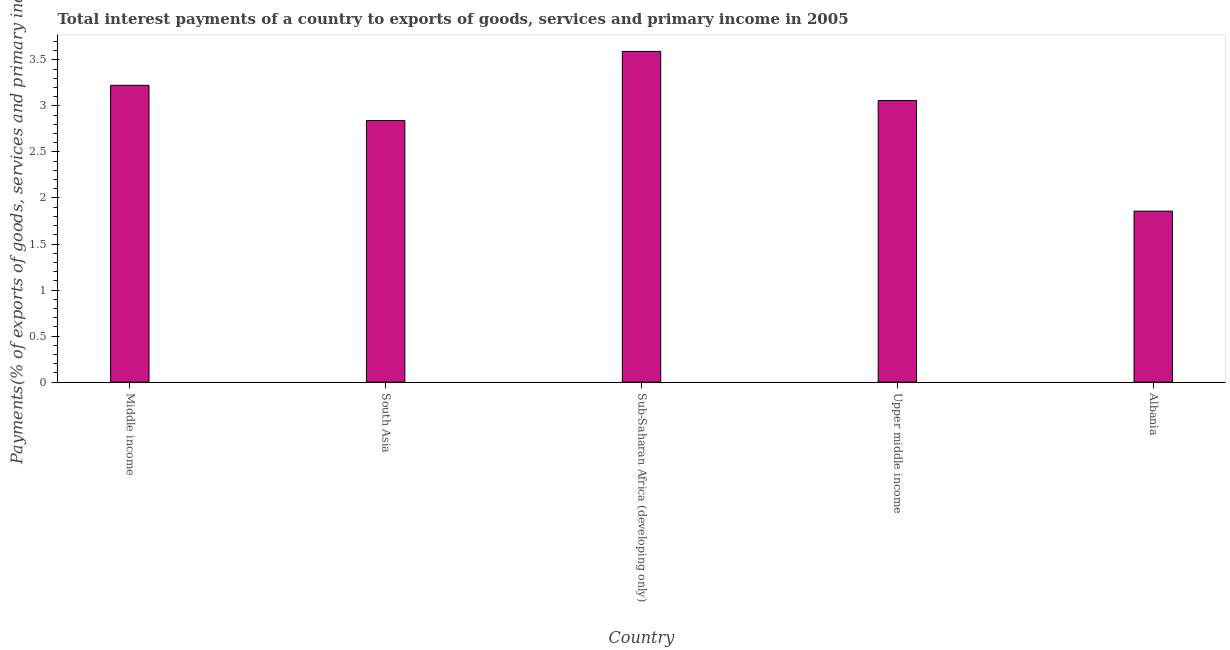Does the graph contain any zero values?
Give a very brief answer. No. What is the title of the graph?
Offer a very short reply. Total interest payments of a country to exports of goods, services and primary income in 2005. What is the label or title of the X-axis?
Your answer should be compact. Country. What is the label or title of the Y-axis?
Your response must be concise. Payments(% of exports of goods, services and primary income). What is the total interest payments on external debt in Albania?
Your answer should be very brief. 1.86. Across all countries, what is the maximum total interest payments on external debt?
Your answer should be compact. 3.59. Across all countries, what is the minimum total interest payments on external debt?
Your answer should be compact. 1.86. In which country was the total interest payments on external debt maximum?
Your response must be concise. Sub-Saharan Africa (developing only). In which country was the total interest payments on external debt minimum?
Your answer should be very brief. Albania. What is the sum of the total interest payments on external debt?
Give a very brief answer. 14.57. What is the difference between the total interest payments on external debt in Sub-Saharan Africa (developing only) and Upper middle income?
Your response must be concise. 0.53. What is the average total interest payments on external debt per country?
Offer a terse response. 2.91. What is the median total interest payments on external debt?
Provide a succinct answer. 3.06. In how many countries, is the total interest payments on external debt greater than 1 %?
Your answer should be very brief. 5. What is the ratio of the total interest payments on external debt in Albania to that in Middle income?
Offer a terse response. 0.58. Is the difference between the total interest payments on external debt in Middle income and South Asia greater than the difference between any two countries?
Give a very brief answer. No. What is the difference between the highest and the second highest total interest payments on external debt?
Offer a terse response. 0.37. Is the sum of the total interest payments on external debt in South Asia and Sub-Saharan Africa (developing only) greater than the maximum total interest payments on external debt across all countries?
Make the answer very short. Yes. What is the difference between the highest and the lowest total interest payments on external debt?
Ensure brevity in your answer.  1.73. Are all the bars in the graph horizontal?
Offer a very short reply. No. How many countries are there in the graph?
Provide a succinct answer. 5. Are the values on the major ticks of Y-axis written in scientific E-notation?
Your answer should be compact. No. What is the Payments(% of exports of goods, services and primary income) in Middle income?
Your response must be concise. 3.22. What is the Payments(% of exports of goods, services and primary income) of South Asia?
Your response must be concise. 2.84. What is the Payments(% of exports of goods, services and primary income) of Sub-Saharan Africa (developing only)?
Make the answer very short. 3.59. What is the Payments(% of exports of goods, services and primary income) of Upper middle income?
Your answer should be compact. 3.06. What is the Payments(% of exports of goods, services and primary income) of Albania?
Provide a short and direct response. 1.86. What is the difference between the Payments(% of exports of goods, services and primary income) in Middle income and South Asia?
Ensure brevity in your answer.  0.38. What is the difference between the Payments(% of exports of goods, services and primary income) in Middle income and Sub-Saharan Africa (developing only)?
Your response must be concise. -0.37. What is the difference between the Payments(% of exports of goods, services and primary income) in Middle income and Upper middle income?
Give a very brief answer. 0.16. What is the difference between the Payments(% of exports of goods, services and primary income) in Middle income and Albania?
Offer a terse response. 1.37. What is the difference between the Payments(% of exports of goods, services and primary income) in South Asia and Sub-Saharan Africa (developing only)?
Offer a very short reply. -0.75. What is the difference between the Payments(% of exports of goods, services and primary income) in South Asia and Upper middle income?
Offer a very short reply. -0.22. What is the difference between the Payments(% of exports of goods, services and primary income) in South Asia and Albania?
Make the answer very short. 0.98. What is the difference between the Payments(% of exports of goods, services and primary income) in Sub-Saharan Africa (developing only) and Upper middle income?
Make the answer very short. 0.53. What is the difference between the Payments(% of exports of goods, services and primary income) in Sub-Saharan Africa (developing only) and Albania?
Offer a very short reply. 1.73. What is the difference between the Payments(% of exports of goods, services and primary income) in Upper middle income and Albania?
Give a very brief answer. 1.2. What is the ratio of the Payments(% of exports of goods, services and primary income) in Middle income to that in South Asia?
Your answer should be very brief. 1.14. What is the ratio of the Payments(% of exports of goods, services and primary income) in Middle income to that in Sub-Saharan Africa (developing only)?
Make the answer very short. 0.9. What is the ratio of the Payments(% of exports of goods, services and primary income) in Middle income to that in Upper middle income?
Your answer should be compact. 1.05. What is the ratio of the Payments(% of exports of goods, services and primary income) in Middle income to that in Albania?
Offer a terse response. 1.74. What is the ratio of the Payments(% of exports of goods, services and primary income) in South Asia to that in Sub-Saharan Africa (developing only)?
Give a very brief answer. 0.79. What is the ratio of the Payments(% of exports of goods, services and primary income) in South Asia to that in Upper middle income?
Your answer should be very brief. 0.93. What is the ratio of the Payments(% of exports of goods, services and primary income) in South Asia to that in Albania?
Provide a succinct answer. 1.53. What is the ratio of the Payments(% of exports of goods, services and primary income) in Sub-Saharan Africa (developing only) to that in Upper middle income?
Ensure brevity in your answer.  1.17. What is the ratio of the Payments(% of exports of goods, services and primary income) in Sub-Saharan Africa (developing only) to that in Albania?
Provide a short and direct response. 1.93. What is the ratio of the Payments(% of exports of goods, services and primary income) in Upper middle income to that in Albania?
Provide a short and direct response. 1.65. 